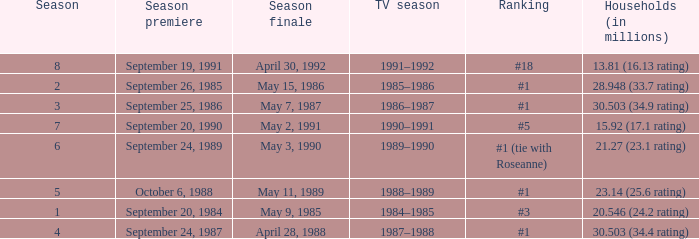Which TV season has a Season larger than 2, and a Ranking of #5? 1990–1991. 